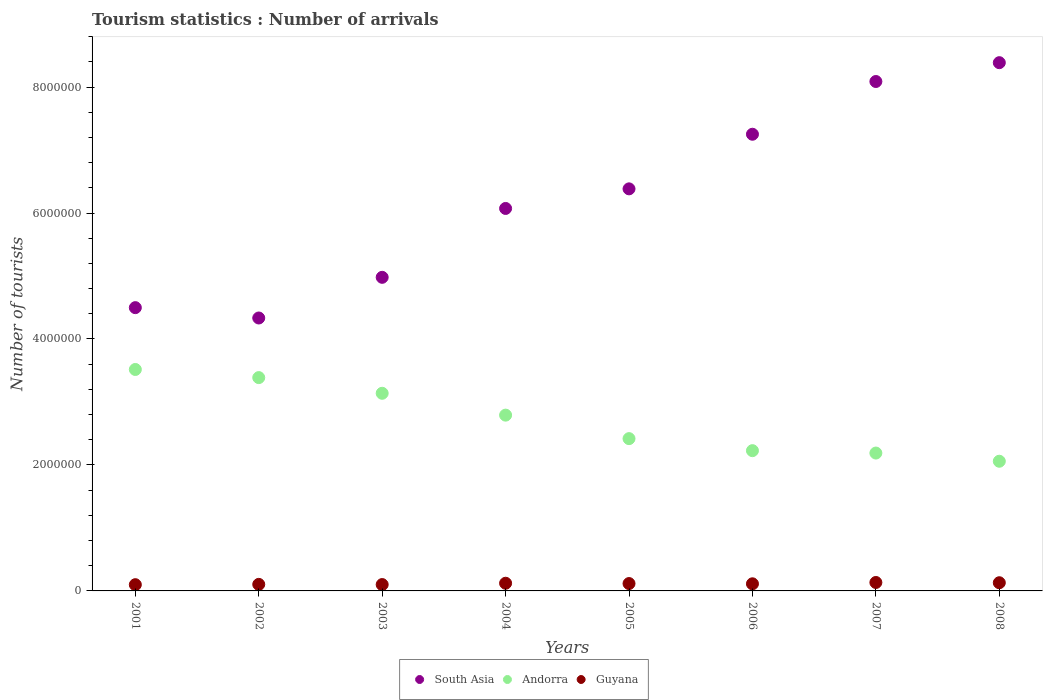Is the number of dotlines equal to the number of legend labels?
Give a very brief answer. Yes. What is the number of tourist arrivals in South Asia in 2003?
Offer a terse response. 4.98e+06. Across all years, what is the maximum number of tourist arrivals in Andorra?
Your answer should be compact. 3.52e+06. Across all years, what is the minimum number of tourist arrivals in Guyana?
Your response must be concise. 9.90e+04. In which year was the number of tourist arrivals in South Asia maximum?
Provide a short and direct response. 2008. What is the total number of tourist arrivals in Andorra in the graph?
Your answer should be compact. 2.17e+07. What is the difference between the number of tourist arrivals in South Asia in 2007 and that in 2008?
Your response must be concise. -2.99e+05. What is the difference between the number of tourist arrivals in Guyana in 2005 and the number of tourist arrivals in South Asia in 2008?
Offer a terse response. -8.27e+06. What is the average number of tourist arrivals in Andorra per year?
Offer a very short reply. 2.72e+06. In the year 2006, what is the difference between the number of tourist arrivals in South Asia and number of tourist arrivals in Guyana?
Provide a short and direct response. 7.14e+06. In how many years, is the number of tourist arrivals in Andorra greater than 8400000?
Offer a very short reply. 0. What is the ratio of the number of tourist arrivals in Guyana in 2003 to that in 2005?
Provide a short and direct response. 0.86. Is the difference between the number of tourist arrivals in South Asia in 2001 and 2007 greater than the difference between the number of tourist arrivals in Guyana in 2001 and 2007?
Keep it short and to the point. No. What is the difference between the highest and the second highest number of tourist arrivals in Guyana?
Keep it short and to the point. 4000. What is the difference between the highest and the lowest number of tourist arrivals in South Asia?
Give a very brief answer. 4.05e+06. In how many years, is the number of tourist arrivals in Andorra greater than the average number of tourist arrivals in Andorra taken over all years?
Offer a terse response. 4. Is the sum of the number of tourist arrivals in South Asia in 2001 and 2005 greater than the maximum number of tourist arrivals in Guyana across all years?
Offer a very short reply. Yes. Is the number of tourist arrivals in Guyana strictly greater than the number of tourist arrivals in South Asia over the years?
Your answer should be very brief. No. Does the graph contain any zero values?
Keep it short and to the point. No. How many legend labels are there?
Provide a succinct answer. 3. How are the legend labels stacked?
Ensure brevity in your answer.  Horizontal. What is the title of the graph?
Your answer should be compact. Tourism statistics : Number of arrivals. Does "Netherlands" appear as one of the legend labels in the graph?
Provide a succinct answer. No. What is the label or title of the Y-axis?
Provide a succinct answer. Number of tourists. What is the Number of tourists in South Asia in 2001?
Your response must be concise. 4.50e+06. What is the Number of tourists in Andorra in 2001?
Offer a terse response. 3.52e+06. What is the Number of tourists in Guyana in 2001?
Your answer should be compact. 9.90e+04. What is the Number of tourists in South Asia in 2002?
Offer a terse response. 4.33e+06. What is the Number of tourists in Andorra in 2002?
Your answer should be very brief. 3.39e+06. What is the Number of tourists of Guyana in 2002?
Keep it short and to the point. 1.04e+05. What is the Number of tourists of South Asia in 2003?
Ensure brevity in your answer.  4.98e+06. What is the Number of tourists in Andorra in 2003?
Give a very brief answer. 3.14e+06. What is the Number of tourists of Guyana in 2003?
Offer a terse response. 1.01e+05. What is the Number of tourists of South Asia in 2004?
Your answer should be very brief. 6.07e+06. What is the Number of tourists of Andorra in 2004?
Give a very brief answer. 2.79e+06. What is the Number of tourists of Guyana in 2004?
Make the answer very short. 1.22e+05. What is the Number of tourists of South Asia in 2005?
Keep it short and to the point. 6.38e+06. What is the Number of tourists of Andorra in 2005?
Offer a terse response. 2.42e+06. What is the Number of tourists in Guyana in 2005?
Provide a short and direct response. 1.17e+05. What is the Number of tourists of South Asia in 2006?
Offer a very short reply. 7.25e+06. What is the Number of tourists of Andorra in 2006?
Give a very brief answer. 2.23e+06. What is the Number of tourists in Guyana in 2006?
Provide a succinct answer. 1.13e+05. What is the Number of tourists in South Asia in 2007?
Your response must be concise. 8.09e+06. What is the Number of tourists in Andorra in 2007?
Offer a very short reply. 2.19e+06. What is the Number of tourists in Guyana in 2007?
Provide a succinct answer. 1.34e+05. What is the Number of tourists of South Asia in 2008?
Offer a terse response. 8.39e+06. What is the Number of tourists of Andorra in 2008?
Your response must be concise. 2.06e+06. What is the Number of tourists in Guyana in 2008?
Offer a terse response. 1.30e+05. Across all years, what is the maximum Number of tourists of South Asia?
Provide a succinct answer. 8.39e+06. Across all years, what is the maximum Number of tourists in Andorra?
Your answer should be compact. 3.52e+06. Across all years, what is the maximum Number of tourists of Guyana?
Your answer should be compact. 1.34e+05. Across all years, what is the minimum Number of tourists of South Asia?
Provide a short and direct response. 4.33e+06. Across all years, what is the minimum Number of tourists of Andorra?
Offer a very short reply. 2.06e+06. Across all years, what is the minimum Number of tourists in Guyana?
Your response must be concise. 9.90e+04. What is the total Number of tourists in South Asia in the graph?
Ensure brevity in your answer.  5.00e+07. What is the total Number of tourists in Andorra in the graph?
Your answer should be compact. 2.17e+07. What is the total Number of tourists of Guyana in the graph?
Provide a succinct answer. 9.20e+05. What is the difference between the Number of tourists in South Asia in 2001 and that in 2002?
Offer a terse response. 1.64e+05. What is the difference between the Number of tourists of Andorra in 2001 and that in 2002?
Make the answer very short. 1.29e+05. What is the difference between the Number of tourists in Guyana in 2001 and that in 2002?
Offer a terse response. -5000. What is the difference between the Number of tourists of South Asia in 2001 and that in 2003?
Provide a succinct answer. -4.81e+05. What is the difference between the Number of tourists of Andorra in 2001 and that in 2003?
Offer a very short reply. 3.78e+05. What is the difference between the Number of tourists of Guyana in 2001 and that in 2003?
Ensure brevity in your answer.  -2000. What is the difference between the Number of tourists of South Asia in 2001 and that in 2004?
Give a very brief answer. -1.58e+06. What is the difference between the Number of tourists in Andorra in 2001 and that in 2004?
Give a very brief answer. 7.25e+05. What is the difference between the Number of tourists in Guyana in 2001 and that in 2004?
Ensure brevity in your answer.  -2.30e+04. What is the difference between the Number of tourists of South Asia in 2001 and that in 2005?
Your answer should be compact. -1.89e+06. What is the difference between the Number of tourists in Andorra in 2001 and that in 2005?
Give a very brief answer. 1.10e+06. What is the difference between the Number of tourists in Guyana in 2001 and that in 2005?
Your answer should be compact. -1.80e+04. What is the difference between the Number of tourists in South Asia in 2001 and that in 2006?
Keep it short and to the point. -2.75e+06. What is the difference between the Number of tourists in Andorra in 2001 and that in 2006?
Your response must be concise. 1.29e+06. What is the difference between the Number of tourists in Guyana in 2001 and that in 2006?
Your answer should be compact. -1.40e+04. What is the difference between the Number of tourists of South Asia in 2001 and that in 2007?
Offer a very short reply. -3.59e+06. What is the difference between the Number of tourists of Andorra in 2001 and that in 2007?
Keep it short and to the point. 1.33e+06. What is the difference between the Number of tourists in Guyana in 2001 and that in 2007?
Your answer should be compact. -3.50e+04. What is the difference between the Number of tourists in South Asia in 2001 and that in 2008?
Provide a short and direct response. -3.89e+06. What is the difference between the Number of tourists in Andorra in 2001 and that in 2008?
Make the answer very short. 1.46e+06. What is the difference between the Number of tourists in Guyana in 2001 and that in 2008?
Provide a short and direct response. -3.10e+04. What is the difference between the Number of tourists in South Asia in 2002 and that in 2003?
Your response must be concise. -6.46e+05. What is the difference between the Number of tourists of Andorra in 2002 and that in 2003?
Make the answer very short. 2.49e+05. What is the difference between the Number of tourists of Guyana in 2002 and that in 2003?
Give a very brief answer. 3000. What is the difference between the Number of tourists in South Asia in 2002 and that in 2004?
Keep it short and to the point. -1.74e+06. What is the difference between the Number of tourists in Andorra in 2002 and that in 2004?
Your answer should be compact. 5.96e+05. What is the difference between the Number of tourists in Guyana in 2002 and that in 2004?
Offer a very short reply. -1.80e+04. What is the difference between the Number of tourists in South Asia in 2002 and that in 2005?
Your answer should be compact. -2.05e+06. What is the difference between the Number of tourists of Andorra in 2002 and that in 2005?
Offer a terse response. 9.69e+05. What is the difference between the Number of tourists of Guyana in 2002 and that in 2005?
Offer a very short reply. -1.30e+04. What is the difference between the Number of tourists in South Asia in 2002 and that in 2006?
Offer a very short reply. -2.92e+06. What is the difference between the Number of tourists of Andorra in 2002 and that in 2006?
Provide a short and direct response. 1.16e+06. What is the difference between the Number of tourists in Guyana in 2002 and that in 2006?
Your answer should be compact. -9000. What is the difference between the Number of tourists of South Asia in 2002 and that in 2007?
Your response must be concise. -3.76e+06. What is the difference between the Number of tourists in Andorra in 2002 and that in 2007?
Ensure brevity in your answer.  1.20e+06. What is the difference between the Number of tourists of Guyana in 2002 and that in 2007?
Your answer should be compact. -3.00e+04. What is the difference between the Number of tourists in South Asia in 2002 and that in 2008?
Your response must be concise. -4.05e+06. What is the difference between the Number of tourists of Andorra in 2002 and that in 2008?
Provide a succinct answer. 1.33e+06. What is the difference between the Number of tourists of Guyana in 2002 and that in 2008?
Give a very brief answer. -2.60e+04. What is the difference between the Number of tourists in South Asia in 2003 and that in 2004?
Your response must be concise. -1.09e+06. What is the difference between the Number of tourists in Andorra in 2003 and that in 2004?
Your answer should be very brief. 3.47e+05. What is the difference between the Number of tourists in Guyana in 2003 and that in 2004?
Make the answer very short. -2.10e+04. What is the difference between the Number of tourists in South Asia in 2003 and that in 2005?
Your answer should be very brief. -1.40e+06. What is the difference between the Number of tourists of Andorra in 2003 and that in 2005?
Your response must be concise. 7.20e+05. What is the difference between the Number of tourists of Guyana in 2003 and that in 2005?
Provide a short and direct response. -1.60e+04. What is the difference between the Number of tourists of South Asia in 2003 and that in 2006?
Offer a very short reply. -2.27e+06. What is the difference between the Number of tourists in Andorra in 2003 and that in 2006?
Offer a terse response. 9.11e+05. What is the difference between the Number of tourists in Guyana in 2003 and that in 2006?
Your response must be concise. -1.20e+04. What is the difference between the Number of tourists of South Asia in 2003 and that in 2007?
Offer a terse response. -3.11e+06. What is the difference between the Number of tourists in Andorra in 2003 and that in 2007?
Keep it short and to the point. 9.49e+05. What is the difference between the Number of tourists of Guyana in 2003 and that in 2007?
Your response must be concise. -3.30e+04. What is the difference between the Number of tourists in South Asia in 2003 and that in 2008?
Keep it short and to the point. -3.41e+06. What is the difference between the Number of tourists in Andorra in 2003 and that in 2008?
Your answer should be very brief. 1.08e+06. What is the difference between the Number of tourists in Guyana in 2003 and that in 2008?
Offer a very short reply. -2.90e+04. What is the difference between the Number of tourists of South Asia in 2004 and that in 2005?
Keep it short and to the point. -3.11e+05. What is the difference between the Number of tourists in Andorra in 2004 and that in 2005?
Your answer should be compact. 3.73e+05. What is the difference between the Number of tourists in Guyana in 2004 and that in 2005?
Ensure brevity in your answer.  5000. What is the difference between the Number of tourists in South Asia in 2004 and that in 2006?
Offer a terse response. -1.18e+06. What is the difference between the Number of tourists in Andorra in 2004 and that in 2006?
Offer a terse response. 5.64e+05. What is the difference between the Number of tourists of Guyana in 2004 and that in 2006?
Offer a very short reply. 9000. What is the difference between the Number of tourists of South Asia in 2004 and that in 2007?
Ensure brevity in your answer.  -2.02e+06. What is the difference between the Number of tourists in Andorra in 2004 and that in 2007?
Give a very brief answer. 6.02e+05. What is the difference between the Number of tourists in Guyana in 2004 and that in 2007?
Provide a short and direct response. -1.20e+04. What is the difference between the Number of tourists of South Asia in 2004 and that in 2008?
Ensure brevity in your answer.  -2.31e+06. What is the difference between the Number of tourists of Andorra in 2004 and that in 2008?
Offer a terse response. 7.32e+05. What is the difference between the Number of tourists of Guyana in 2004 and that in 2008?
Ensure brevity in your answer.  -8000. What is the difference between the Number of tourists of South Asia in 2005 and that in 2006?
Keep it short and to the point. -8.67e+05. What is the difference between the Number of tourists in Andorra in 2005 and that in 2006?
Offer a terse response. 1.91e+05. What is the difference between the Number of tourists in Guyana in 2005 and that in 2006?
Provide a short and direct response. 4000. What is the difference between the Number of tourists of South Asia in 2005 and that in 2007?
Offer a very short reply. -1.70e+06. What is the difference between the Number of tourists in Andorra in 2005 and that in 2007?
Offer a very short reply. 2.29e+05. What is the difference between the Number of tourists of Guyana in 2005 and that in 2007?
Provide a succinct answer. -1.70e+04. What is the difference between the Number of tourists of South Asia in 2005 and that in 2008?
Make the answer very short. -2.00e+06. What is the difference between the Number of tourists in Andorra in 2005 and that in 2008?
Keep it short and to the point. 3.59e+05. What is the difference between the Number of tourists in Guyana in 2005 and that in 2008?
Offer a terse response. -1.30e+04. What is the difference between the Number of tourists of South Asia in 2006 and that in 2007?
Keep it short and to the point. -8.38e+05. What is the difference between the Number of tourists in Andorra in 2006 and that in 2007?
Offer a terse response. 3.80e+04. What is the difference between the Number of tourists in Guyana in 2006 and that in 2007?
Ensure brevity in your answer.  -2.10e+04. What is the difference between the Number of tourists in South Asia in 2006 and that in 2008?
Offer a very short reply. -1.14e+06. What is the difference between the Number of tourists of Andorra in 2006 and that in 2008?
Provide a short and direct response. 1.68e+05. What is the difference between the Number of tourists of Guyana in 2006 and that in 2008?
Offer a very short reply. -1.70e+04. What is the difference between the Number of tourists of South Asia in 2007 and that in 2008?
Make the answer very short. -2.99e+05. What is the difference between the Number of tourists of Andorra in 2007 and that in 2008?
Offer a terse response. 1.30e+05. What is the difference between the Number of tourists of Guyana in 2007 and that in 2008?
Provide a succinct answer. 4000. What is the difference between the Number of tourists of South Asia in 2001 and the Number of tourists of Andorra in 2002?
Your answer should be compact. 1.11e+06. What is the difference between the Number of tourists of South Asia in 2001 and the Number of tourists of Guyana in 2002?
Provide a succinct answer. 4.39e+06. What is the difference between the Number of tourists in Andorra in 2001 and the Number of tourists in Guyana in 2002?
Keep it short and to the point. 3.41e+06. What is the difference between the Number of tourists in South Asia in 2001 and the Number of tourists in Andorra in 2003?
Ensure brevity in your answer.  1.36e+06. What is the difference between the Number of tourists in South Asia in 2001 and the Number of tourists in Guyana in 2003?
Offer a terse response. 4.40e+06. What is the difference between the Number of tourists of Andorra in 2001 and the Number of tourists of Guyana in 2003?
Offer a very short reply. 3.42e+06. What is the difference between the Number of tourists of South Asia in 2001 and the Number of tourists of Andorra in 2004?
Your answer should be compact. 1.71e+06. What is the difference between the Number of tourists in South Asia in 2001 and the Number of tourists in Guyana in 2004?
Make the answer very short. 4.38e+06. What is the difference between the Number of tourists of Andorra in 2001 and the Number of tourists of Guyana in 2004?
Offer a very short reply. 3.39e+06. What is the difference between the Number of tourists in South Asia in 2001 and the Number of tourists in Andorra in 2005?
Your response must be concise. 2.08e+06. What is the difference between the Number of tourists in South Asia in 2001 and the Number of tourists in Guyana in 2005?
Make the answer very short. 4.38e+06. What is the difference between the Number of tourists in Andorra in 2001 and the Number of tourists in Guyana in 2005?
Your answer should be compact. 3.40e+06. What is the difference between the Number of tourists in South Asia in 2001 and the Number of tourists in Andorra in 2006?
Keep it short and to the point. 2.27e+06. What is the difference between the Number of tourists of South Asia in 2001 and the Number of tourists of Guyana in 2006?
Provide a succinct answer. 4.38e+06. What is the difference between the Number of tourists in Andorra in 2001 and the Number of tourists in Guyana in 2006?
Your response must be concise. 3.40e+06. What is the difference between the Number of tourists in South Asia in 2001 and the Number of tourists in Andorra in 2007?
Give a very brief answer. 2.31e+06. What is the difference between the Number of tourists in South Asia in 2001 and the Number of tourists in Guyana in 2007?
Offer a very short reply. 4.36e+06. What is the difference between the Number of tourists of Andorra in 2001 and the Number of tourists of Guyana in 2007?
Your answer should be compact. 3.38e+06. What is the difference between the Number of tourists in South Asia in 2001 and the Number of tourists in Andorra in 2008?
Give a very brief answer. 2.44e+06. What is the difference between the Number of tourists in South Asia in 2001 and the Number of tourists in Guyana in 2008?
Ensure brevity in your answer.  4.37e+06. What is the difference between the Number of tourists in Andorra in 2001 and the Number of tourists in Guyana in 2008?
Provide a short and direct response. 3.39e+06. What is the difference between the Number of tourists in South Asia in 2002 and the Number of tourists in Andorra in 2003?
Your answer should be compact. 1.20e+06. What is the difference between the Number of tourists in South Asia in 2002 and the Number of tourists in Guyana in 2003?
Offer a very short reply. 4.23e+06. What is the difference between the Number of tourists in Andorra in 2002 and the Number of tourists in Guyana in 2003?
Offer a terse response. 3.29e+06. What is the difference between the Number of tourists in South Asia in 2002 and the Number of tourists in Andorra in 2004?
Give a very brief answer. 1.54e+06. What is the difference between the Number of tourists of South Asia in 2002 and the Number of tourists of Guyana in 2004?
Provide a succinct answer. 4.21e+06. What is the difference between the Number of tourists in Andorra in 2002 and the Number of tourists in Guyana in 2004?
Your response must be concise. 3.26e+06. What is the difference between the Number of tourists in South Asia in 2002 and the Number of tourists in Andorra in 2005?
Your response must be concise. 1.92e+06. What is the difference between the Number of tourists of South Asia in 2002 and the Number of tourists of Guyana in 2005?
Provide a short and direct response. 4.22e+06. What is the difference between the Number of tourists in Andorra in 2002 and the Number of tourists in Guyana in 2005?
Provide a succinct answer. 3.27e+06. What is the difference between the Number of tourists in South Asia in 2002 and the Number of tourists in Andorra in 2006?
Provide a short and direct response. 2.11e+06. What is the difference between the Number of tourists in South Asia in 2002 and the Number of tourists in Guyana in 2006?
Your answer should be compact. 4.22e+06. What is the difference between the Number of tourists in Andorra in 2002 and the Number of tourists in Guyana in 2006?
Offer a very short reply. 3.27e+06. What is the difference between the Number of tourists in South Asia in 2002 and the Number of tourists in Andorra in 2007?
Your answer should be very brief. 2.14e+06. What is the difference between the Number of tourists of South Asia in 2002 and the Number of tourists of Guyana in 2007?
Offer a very short reply. 4.20e+06. What is the difference between the Number of tourists in Andorra in 2002 and the Number of tourists in Guyana in 2007?
Your response must be concise. 3.25e+06. What is the difference between the Number of tourists of South Asia in 2002 and the Number of tourists of Andorra in 2008?
Offer a very short reply. 2.27e+06. What is the difference between the Number of tourists in South Asia in 2002 and the Number of tourists in Guyana in 2008?
Ensure brevity in your answer.  4.20e+06. What is the difference between the Number of tourists of Andorra in 2002 and the Number of tourists of Guyana in 2008?
Your answer should be compact. 3.26e+06. What is the difference between the Number of tourists in South Asia in 2003 and the Number of tourists in Andorra in 2004?
Make the answer very short. 2.19e+06. What is the difference between the Number of tourists of South Asia in 2003 and the Number of tourists of Guyana in 2004?
Your answer should be very brief. 4.86e+06. What is the difference between the Number of tourists in Andorra in 2003 and the Number of tourists in Guyana in 2004?
Your answer should be compact. 3.02e+06. What is the difference between the Number of tourists of South Asia in 2003 and the Number of tourists of Andorra in 2005?
Your answer should be compact. 2.56e+06. What is the difference between the Number of tourists in South Asia in 2003 and the Number of tourists in Guyana in 2005?
Provide a succinct answer. 4.86e+06. What is the difference between the Number of tourists of Andorra in 2003 and the Number of tourists of Guyana in 2005?
Provide a succinct answer. 3.02e+06. What is the difference between the Number of tourists of South Asia in 2003 and the Number of tourists of Andorra in 2006?
Ensure brevity in your answer.  2.75e+06. What is the difference between the Number of tourists of South Asia in 2003 and the Number of tourists of Guyana in 2006?
Ensure brevity in your answer.  4.87e+06. What is the difference between the Number of tourists of Andorra in 2003 and the Number of tourists of Guyana in 2006?
Keep it short and to the point. 3.02e+06. What is the difference between the Number of tourists of South Asia in 2003 and the Number of tourists of Andorra in 2007?
Your answer should be compact. 2.79e+06. What is the difference between the Number of tourists in South Asia in 2003 and the Number of tourists in Guyana in 2007?
Provide a short and direct response. 4.85e+06. What is the difference between the Number of tourists of Andorra in 2003 and the Number of tourists of Guyana in 2007?
Offer a very short reply. 3.00e+06. What is the difference between the Number of tourists in South Asia in 2003 and the Number of tourists in Andorra in 2008?
Keep it short and to the point. 2.92e+06. What is the difference between the Number of tourists of South Asia in 2003 and the Number of tourists of Guyana in 2008?
Your answer should be very brief. 4.85e+06. What is the difference between the Number of tourists of Andorra in 2003 and the Number of tourists of Guyana in 2008?
Keep it short and to the point. 3.01e+06. What is the difference between the Number of tourists of South Asia in 2004 and the Number of tourists of Andorra in 2005?
Offer a very short reply. 3.65e+06. What is the difference between the Number of tourists in South Asia in 2004 and the Number of tourists in Guyana in 2005?
Provide a succinct answer. 5.96e+06. What is the difference between the Number of tourists of Andorra in 2004 and the Number of tourists of Guyana in 2005?
Offer a very short reply. 2.67e+06. What is the difference between the Number of tourists of South Asia in 2004 and the Number of tourists of Andorra in 2006?
Your answer should be very brief. 3.85e+06. What is the difference between the Number of tourists in South Asia in 2004 and the Number of tourists in Guyana in 2006?
Make the answer very short. 5.96e+06. What is the difference between the Number of tourists of Andorra in 2004 and the Number of tourists of Guyana in 2006?
Your answer should be compact. 2.68e+06. What is the difference between the Number of tourists in South Asia in 2004 and the Number of tourists in Andorra in 2007?
Your answer should be very brief. 3.88e+06. What is the difference between the Number of tourists in South Asia in 2004 and the Number of tourists in Guyana in 2007?
Provide a short and direct response. 5.94e+06. What is the difference between the Number of tourists in Andorra in 2004 and the Number of tourists in Guyana in 2007?
Provide a short and direct response. 2.66e+06. What is the difference between the Number of tourists in South Asia in 2004 and the Number of tourists in Andorra in 2008?
Keep it short and to the point. 4.01e+06. What is the difference between the Number of tourists in South Asia in 2004 and the Number of tourists in Guyana in 2008?
Give a very brief answer. 5.94e+06. What is the difference between the Number of tourists in Andorra in 2004 and the Number of tourists in Guyana in 2008?
Offer a very short reply. 2.66e+06. What is the difference between the Number of tourists in South Asia in 2005 and the Number of tourists in Andorra in 2006?
Ensure brevity in your answer.  4.16e+06. What is the difference between the Number of tourists of South Asia in 2005 and the Number of tourists of Guyana in 2006?
Provide a succinct answer. 6.27e+06. What is the difference between the Number of tourists of Andorra in 2005 and the Number of tourists of Guyana in 2006?
Keep it short and to the point. 2.30e+06. What is the difference between the Number of tourists in South Asia in 2005 and the Number of tourists in Andorra in 2007?
Your answer should be very brief. 4.19e+06. What is the difference between the Number of tourists in South Asia in 2005 and the Number of tourists in Guyana in 2007?
Provide a succinct answer. 6.25e+06. What is the difference between the Number of tourists in Andorra in 2005 and the Number of tourists in Guyana in 2007?
Provide a short and direct response. 2.28e+06. What is the difference between the Number of tourists in South Asia in 2005 and the Number of tourists in Andorra in 2008?
Keep it short and to the point. 4.32e+06. What is the difference between the Number of tourists of South Asia in 2005 and the Number of tourists of Guyana in 2008?
Provide a short and direct response. 6.25e+06. What is the difference between the Number of tourists in Andorra in 2005 and the Number of tourists in Guyana in 2008?
Provide a short and direct response. 2.29e+06. What is the difference between the Number of tourists of South Asia in 2006 and the Number of tourists of Andorra in 2007?
Offer a very short reply. 5.06e+06. What is the difference between the Number of tourists of South Asia in 2006 and the Number of tourists of Guyana in 2007?
Offer a terse response. 7.12e+06. What is the difference between the Number of tourists in Andorra in 2006 and the Number of tourists in Guyana in 2007?
Provide a short and direct response. 2.09e+06. What is the difference between the Number of tourists of South Asia in 2006 and the Number of tourists of Andorra in 2008?
Make the answer very short. 5.19e+06. What is the difference between the Number of tourists in South Asia in 2006 and the Number of tourists in Guyana in 2008?
Make the answer very short. 7.12e+06. What is the difference between the Number of tourists of Andorra in 2006 and the Number of tourists of Guyana in 2008?
Make the answer very short. 2.10e+06. What is the difference between the Number of tourists in South Asia in 2007 and the Number of tourists in Andorra in 2008?
Your answer should be very brief. 6.03e+06. What is the difference between the Number of tourists in South Asia in 2007 and the Number of tourists in Guyana in 2008?
Give a very brief answer. 7.96e+06. What is the difference between the Number of tourists of Andorra in 2007 and the Number of tourists of Guyana in 2008?
Offer a very short reply. 2.06e+06. What is the average Number of tourists of South Asia per year?
Provide a succinct answer. 6.25e+06. What is the average Number of tourists of Andorra per year?
Offer a very short reply. 2.72e+06. What is the average Number of tourists of Guyana per year?
Ensure brevity in your answer.  1.15e+05. In the year 2001, what is the difference between the Number of tourists in South Asia and Number of tourists in Andorra?
Your answer should be compact. 9.82e+05. In the year 2001, what is the difference between the Number of tourists in South Asia and Number of tourists in Guyana?
Provide a short and direct response. 4.40e+06. In the year 2001, what is the difference between the Number of tourists of Andorra and Number of tourists of Guyana?
Give a very brief answer. 3.42e+06. In the year 2002, what is the difference between the Number of tourists of South Asia and Number of tourists of Andorra?
Your answer should be very brief. 9.46e+05. In the year 2002, what is the difference between the Number of tourists in South Asia and Number of tourists in Guyana?
Your answer should be compact. 4.23e+06. In the year 2002, what is the difference between the Number of tourists of Andorra and Number of tourists of Guyana?
Your answer should be compact. 3.28e+06. In the year 2003, what is the difference between the Number of tourists in South Asia and Number of tourists in Andorra?
Your response must be concise. 1.84e+06. In the year 2003, what is the difference between the Number of tourists in South Asia and Number of tourists in Guyana?
Ensure brevity in your answer.  4.88e+06. In the year 2003, what is the difference between the Number of tourists in Andorra and Number of tourists in Guyana?
Your answer should be compact. 3.04e+06. In the year 2004, what is the difference between the Number of tourists in South Asia and Number of tourists in Andorra?
Your answer should be very brief. 3.28e+06. In the year 2004, what is the difference between the Number of tourists in South Asia and Number of tourists in Guyana?
Keep it short and to the point. 5.95e+06. In the year 2004, what is the difference between the Number of tourists of Andorra and Number of tourists of Guyana?
Your answer should be very brief. 2.67e+06. In the year 2005, what is the difference between the Number of tourists of South Asia and Number of tourists of Andorra?
Offer a very short reply. 3.97e+06. In the year 2005, what is the difference between the Number of tourists of South Asia and Number of tourists of Guyana?
Offer a terse response. 6.27e+06. In the year 2005, what is the difference between the Number of tourists of Andorra and Number of tourists of Guyana?
Keep it short and to the point. 2.30e+06. In the year 2006, what is the difference between the Number of tourists of South Asia and Number of tourists of Andorra?
Give a very brief answer. 5.02e+06. In the year 2006, what is the difference between the Number of tourists in South Asia and Number of tourists in Guyana?
Give a very brief answer. 7.14e+06. In the year 2006, what is the difference between the Number of tourists of Andorra and Number of tourists of Guyana?
Your response must be concise. 2.11e+06. In the year 2007, what is the difference between the Number of tourists of South Asia and Number of tourists of Andorra?
Offer a very short reply. 5.90e+06. In the year 2007, what is the difference between the Number of tourists of South Asia and Number of tourists of Guyana?
Your answer should be compact. 7.95e+06. In the year 2007, what is the difference between the Number of tourists of Andorra and Number of tourists of Guyana?
Make the answer very short. 2.06e+06. In the year 2008, what is the difference between the Number of tourists in South Asia and Number of tourists in Andorra?
Offer a very short reply. 6.33e+06. In the year 2008, what is the difference between the Number of tourists in South Asia and Number of tourists in Guyana?
Provide a short and direct response. 8.26e+06. In the year 2008, what is the difference between the Number of tourists of Andorra and Number of tourists of Guyana?
Your answer should be compact. 1.93e+06. What is the ratio of the Number of tourists in South Asia in 2001 to that in 2002?
Your response must be concise. 1.04. What is the ratio of the Number of tourists of Andorra in 2001 to that in 2002?
Your response must be concise. 1.04. What is the ratio of the Number of tourists of Guyana in 2001 to that in 2002?
Keep it short and to the point. 0.95. What is the ratio of the Number of tourists in South Asia in 2001 to that in 2003?
Make the answer very short. 0.9. What is the ratio of the Number of tourists in Andorra in 2001 to that in 2003?
Offer a terse response. 1.12. What is the ratio of the Number of tourists of Guyana in 2001 to that in 2003?
Provide a short and direct response. 0.98. What is the ratio of the Number of tourists of South Asia in 2001 to that in 2004?
Make the answer very short. 0.74. What is the ratio of the Number of tourists of Andorra in 2001 to that in 2004?
Your response must be concise. 1.26. What is the ratio of the Number of tourists in Guyana in 2001 to that in 2004?
Your answer should be very brief. 0.81. What is the ratio of the Number of tourists in South Asia in 2001 to that in 2005?
Your response must be concise. 0.7. What is the ratio of the Number of tourists of Andorra in 2001 to that in 2005?
Give a very brief answer. 1.45. What is the ratio of the Number of tourists in Guyana in 2001 to that in 2005?
Offer a very short reply. 0.85. What is the ratio of the Number of tourists of South Asia in 2001 to that in 2006?
Offer a very short reply. 0.62. What is the ratio of the Number of tourists in Andorra in 2001 to that in 2006?
Offer a very short reply. 1.58. What is the ratio of the Number of tourists in Guyana in 2001 to that in 2006?
Keep it short and to the point. 0.88. What is the ratio of the Number of tourists in South Asia in 2001 to that in 2007?
Offer a very short reply. 0.56. What is the ratio of the Number of tourists in Andorra in 2001 to that in 2007?
Your answer should be compact. 1.61. What is the ratio of the Number of tourists in Guyana in 2001 to that in 2007?
Keep it short and to the point. 0.74. What is the ratio of the Number of tourists in South Asia in 2001 to that in 2008?
Your answer should be very brief. 0.54. What is the ratio of the Number of tourists in Andorra in 2001 to that in 2008?
Keep it short and to the point. 1.71. What is the ratio of the Number of tourists of Guyana in 2001 to that in 2008?
Your response must be concise. 0.76. What is the ratio of the Number of tourists in South Asia in 2002 to that in 2003?
Your answer should be compact. 0.87. What is the ratio of the Number of tourists in Andorra in 2002 to that in 2003?
Make the answer very short. 1.08. What is the ratio of the Number of tourists of Guyana in 2002 to that in 2003?
Make the answer very short. 1.03. What is the ratio of the Number of tourists of South Asia in 2002 to that in 2004?
Offer a terse response. 0.71. What is the ratio of the Number of tourists of Andorra in 2002 to that in 2004?
Ensure brevity in your answer.  1.21. What is the ratio of the Number of tourists in Guyana in 2002 to that in 2004?
Your answer should be very brief. 0.85. What is the ratio of the Number of tourists of South Asia in 2002 to that in 2005?
Your response must be concise. 0.68. What is the ratio of the Number of tourists of Andorra in 2002 to that in 2005?
Offer a terse response. 1.4. What is the ratio of the Number of tourists of South Asia in 2002 to that in 2006?
Keep it short and to the point. 0.6. What is the ratio of the Number of tourists of Andorra in 2002 to that in 2006?
Your answer should be very brief. 1.52. What is the ratio of the Number of tourists in Guyana in 2002 to that in 2006?
Ensure brevity in your answer.  0.92. What is the ratio of the Number of tourists in South Asia in 2002 to that in 2007?
Your answer should be compact. 0.54. What is the ratio of the Number of tourists in Andorra in 2002 to that in 2007?
Give a very brief answer. 1.55. What is the ratio of the Number of tourists of Guyana in 2002 to that in 2007?
Your answer should be very brief. 0.78. What is the ratio of the Number of tourists in South Asia in 2002 to that in 2008?
Offer a terse response. 0.52. What is the ratio of the Number of tourists of Andorra in 2002 to that in 2008?
Offer a terse response. 1.65. What is the ratio of the Number of tourists of Guyana in 2002 to that in 2008?
Your answer should be very brief. 0.8. What is the ratio of the Number of tourists in South Asia in 2003 to that in 2004?
Provide a short and direct response. 0.82. What is the ratio of the Number of tourists in Andorra in 2003 to that in 2004?
Offer a terse response. 1.12. What is the ratio of the Number of tourists in Guyana in 2003 to that in 2004?
Provide a short and direct response. 0.83. What is the ratio of the Number of tourists of South Asia in 2003 to that in 2005?
Ensure brevity in your answer.  0.78. What is the ratio of the Number of tourists of Andorra in 2003 to that in 2005?
Keep it short and to the point. 1.3. What is the ratio of the Number of tourists in Guyana in 2003 to that in 2005?
Offer a terse response. 0.86. What is the ratio of the Number of tourists of South Asia in 2003 to that in 2006?
Offer a very short reply. 0.69. What is the ratio of the Number of tourists in Andorra in 2003 to that in 2006?
Offer a terse response. 1.41. What is the ratio of the Number of tourists of Guyana in 2003 to that in 2006?
Keep it short and to the point. 0.89. What is the ratio of the Number of tourists of South Asia in 2003 to that in 2007?
Ensure brevity in your answer.  0.62. What is the ratio of the Number of tourists in Andorra in 2003 to that in 2007?
Provide a succinct answer. 1.43. What is the ratio of the Number of tourists in Guyana in 2003 to that in 2007?
Offer a very short reply. 0.75. What is the ratio of the Number of tourists in South Asia in 2003 to that in 2008?
Offer a terse response. 0.59. What is the ratio of the Number of tourists of Andorra in 2003 to that in 2008?
Give a very brief answer. 1.52. What is the ratio of the Number of tourists in Guyana in 2003 to that in 2008?
Provide a succinct answer. 0.78. What is the ratio of the Number of tourists in South Asia in 2004 to that in 2005?
Provide a succinct answer. 0.95. What is the ratio of the Number of tourists of Andorra in 2004 to that in 2005?
Your response must be concise. 1.15. What is the ratio of the Number of tourists of Guyana in 2004 to that in 2005?
Keep it short and to the point. 1.04. What is the ratio of the Number of tourists in South Asia in 2004 to that in 2006?
Provide a short and direct response. 0.84. What is the ratio of the Number of tourists in Andorra in 2004 to that in 2006?
Your answer should be compact. 1.25. What is the ratio of the Number of tourists of Guyana in 2004 to that in 2006?
Offer a very short reply. 1.08. What is the ratio of the Number of tourists in South Asia in 2004 to that in 2007?
Your response must be concise. 0.75. What is the ratio of the Number of tourists of Andorra in 2004 to that in 2007?
Offer a very short reply. 1.27. What is the ratio of the Number of tourists in Guyana in 2004 to that in 2007?
Provide a short and direct response. 0.91. What is the ratio of the Number of tourists in South Asia in 2004 to that in 2008?
Provide a succinct answer. 0.72. What is the ratio of the Number of tourists of Andorra in 2004 to that in 2008?
Your answer should be very brief. 1.36. What is the ratio of the Number of tourists of Guyana in 2004 to that in 2008?
Offer a very short reply. 0.94. What is the ratio of the Number of tourists in South Asia in 2005 to that in 2006?
Make the answer very short. 0.88. What is the ratio of the Number of tourists in Andorra in 2005 to that in 2006?
Ensure brevity in your answer.  1.09. What is the ratio of the Number of tourists of Guyana in 2005 to that in 2006?
Offer a terse response. 1.04. What is the ratio of the Number of tourists of South Asia in 2005 to that in 2007?
Offer a terse response. 0.79. What is the ratio of the Number of tourists in Andorra in 2005 to that in 2007?
Make the answer very short. 1.1. What is the ratio of the Number of tourists of Guyana in 2005 to that in 2007?
Your response must be concise. 0.87. What is the ratio of the Number of tourists of South Asia in 2005 to that in 2008?
Make the answer very short. 0.76. What is the ratio of the Number of tourists in Andorra in 2005 to that in 2008?
Your answer should be very brief. 1.17. What is the ratio of the Number of tourists in South Asia in 2006 to that in 2007?
Your answer should be compact. 0.9. What is the ratio of the Number of tourists of Andorra in 2006 to that in 2007?
Offer a terse response. 1.02. What is the ratio of the Number of tourists in Guyana in 2006 to that in 2007?
Keep it short and to the point. 0.84. What is the ratio of the Number of tourists in South Asia in 2006 to that in 2008?
Provide a short and direct response. 0.86. What is the ratio of the Number of tourists in Andorra in 2006 to that in 2008?
Provide a succinct answer. 1.08. What is the ratio of the Number of tourists in Guyana in 2006 to that in 2008?
Make the answer very short. 0.87. What is the ratio of the Number of tourists in South Asia in 2007 to that in 2008?
Make the answer very short. 0.96. What is the ratio of the Number of tourists of Andorra in 2007 to that in 2008?
Keep it short and to the point. 1.06. What is the ratio of the Number of tourists of Guyana in 2007 to that in 2008?
Your answer should be compact. 1.03. What is the difference between the highest and the second highest Number of tourists in South Asia?
Offer a very short reply. 2.99e+05. What is the difference between the highest and the second highest Number of tourists of Andorra?
Provide a short and direct response. 1.29e+05. What is the difference between the highest and the second highest Number of tourists of Guyana?
Provide a succinct answer. 4000. What is the difference between the highest and the lowest Number of tourists in South Asia?
Offer a terse response. 4.05e+06. What is the difference between the highest and the lowest Number of tourists of Andorra?
Provide a short and direct response. 1.46e+06. What is the difference between the highest and the lowest Number of tourists in Guyana?
Keep it short and to the point. 3.50e+04. 